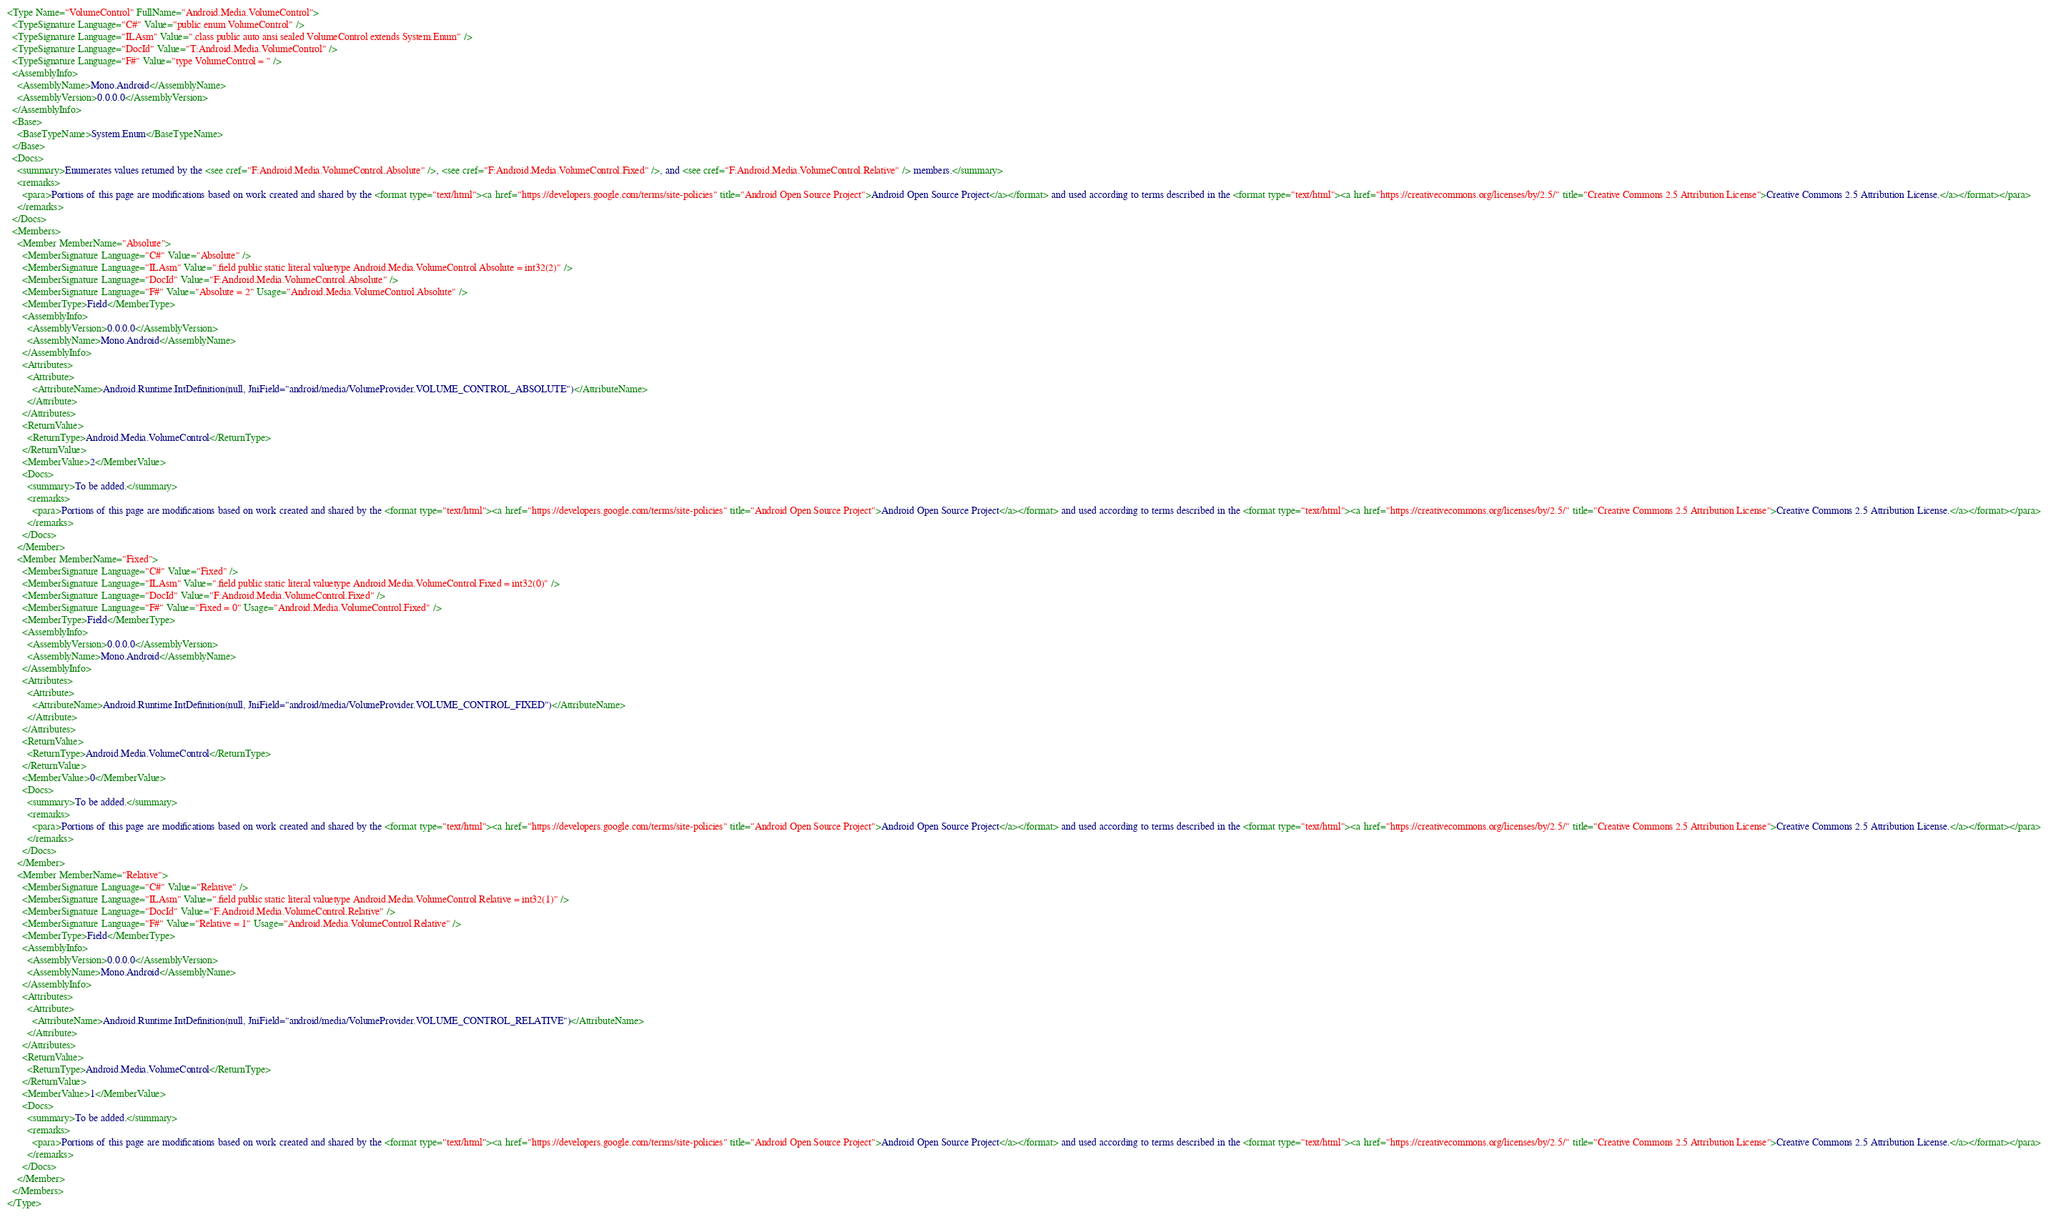Convert code to text. <code><loc_0><loc_0><loc_500><loc_500><_XML_><Type Name="VolumeControl" FullName="Android.Media.VolumeControl">
  <TypeSignature Language="C#" Value="public enum VolumeControl" />
  <TypeSignature Language="ILAsm" Value=".class public auto ansi sealed VolumeControl extends System.Enum" />
  <TypeSignature Language="DocId" Value="T:Android.Media.VolumeControl" />
  <TypeSignature Language="F#" Value="type VolumeControl = " />
  <AssemblyInfo>
    <AssemblyName>Mono.Android</AssemblyName>
    <AssemblyVersion>0.0.0.0</AssemblyVersion>
  </AssemblyInfo>
  <Base>
    <BaseTypeName>System.Enum</BaseTypeName>
  </Base>
  <Docs>
    <summary>Enumerates values returned by the <see cref="F:Android.Media.VolumeControl.Absolute" />, <see cref="F:Android.Media.VolumeControl.Fixed" />, and <see cref="F:Android.Media.VolumeControl.Relative" /> members.</summary>
    <remarks>
      <para>Portions of this page are modifications based on work created and shared by the <format type="text/html"><a href="https://developers.google.com/terms/site-policies" title="Android Open Source Project">Android Open Source Project</a></format> and used according to terms described in the <format type="text/html"><a href="https://creativecommons.org/licenses/by/2.5/" title="Creative Commons 2.5 Attribution License">Creative Commons 2.5 Attribution License.</a></format></para>
    </remarks>
  </Docs>
  <Members>
    <Member MemberName="Absolute">
      <MemberSignature Language="C#" Value="Absolute" />
      <MemberSignature Language="ILAsm" Value=".field public static literal valuetype Android.Media.VolumeControl Absolute = int32(2)" />
      <MemberSignature Language="DocId" Value="F:Android.Media.VolumeControl.Absolute" />
      <MemberSignature Language="F#" Value="Absolute = 2" Usage="Android.Media.VolumeControl.Absolute" />
      <MemberType>Field</MemberType>
      <AssemblyInfo>
        <AssemblyVersion>0.0.0.0</AssemblyVersion>
        <AssemblyName>Mono.Android</AssemblyName>
      </AssemblyInfo>
      <Attributes>
        <Attribute>
          <AttributeName>Android.Runtime.IntDefinition(null, JniField="android/media/VolumeProvider.VOLUME_CONTROL_ABSOLUTE")</AttributeName>
        </Attribute>
      </Attributes>
      <ReturnValue>
        <ReturnType>Android.Media.VolumeControl</ReturnType>
      </ReturnValue>
      <MemberValue>2</MemberValue>
      <Docs>
        <summary>To be added.</summary>
        <remarks>
          <para>Portions of this page are modifications based on work created and shared by the <format type="text/html"><a href="https://developers.google.com/terms/site-policies" title="Android Open Source Project">Android Open Source Project</a></format> and used according to terms described in the <format type="text/html"><a href="https://creativecommons.org/licenses/by/2.5/" title="Creative Commons 2.5 Attribution License">Creative Commons 2.5 Attribution License.</a></format></para>
        </remarks>
      </Docs>
    </Member>
    <Member MemberName="Fixed">
      <MemberSignature Language="C#" Value="Fixed" />
      <MemberSignature Language="ILAsm" Value=".field public static literal valuetype Android.Media.VolumeControl Fixed = int32(0)" />
      <MemberSignature Language="DocId" Value="F:Android.Media.VolumeControl.Fixed" />
      <MemberSignature Language="F#" Value="Fixed = 0" Usage="Android.Media.VolumeControl.Fixed" />
      <MemberType>Field</MemberType>
      <AssemblyInfo>
        <AssemblyVersion>0.0.0.0</AssemblyVersion>
        <AssemblyName>Mono.Android</AssemblyName>
      </AssemblyInfo>
      <Attributes>
        <Attribute>
          <AttributeName>Android.Runtime.IntDefinition(null, JniField="android/media/VolumeProvider.VOLUME_CONTROL_FIXED")</AttributeName>
        </Attribute>
      </Attributes>
      <ReturnValue>
        <ReturnType>Android.Media.VolumeControl</ReturnType>
      </ReturnValue>
      <MemberValue>0</MemberValue>
      <Docs>
        <summary>To be added.</summary>
        <remarks>
          <para>Portions of this page are modifications based on work created and shared by the <format type="text/html"><a href="https://developers.google.com/terms/site-policies" title="Android Open Source Project">Android Open Source Project</a></format> and used according to terms described in the <format type="text/html"><a href="https://creativecommons.org/licenses/by/2.5/" title="Creative Commons 2.5 Attribution License">Creative Commons 2.5 Attribution License.</a></format></para>
        </remarks>
      </Docs>
    </Member>
    <Member MemberName="Relative">
      <MemberSignature Language="C#" Value="Relative" />
      <MemberSignature Language="ILAsm" Value=".field public static literal valuetype Android.Media.VolumeControl Relative = int32(1)" />
      <MemberSignature Language="DocId" Value="F:Android.Media.VolumeControl.Relative" />
      <MemberSignature Language="F#" Value="Relative = 1" Usage="Android.Media.VolumeControl.Relative" />
      <MemberType>Field</MemberType>
      <AssemblyInfo>
        <AssemblyVersion>0.0.0.0</AssemblyVersion>
        <AssemblyName>Mono.Android</AssemblyName>
      </AssemblyInfo>
      <Attributes>
        <Attribute>
          <AttributeName>Android.Runtime.IntDefinition(null, JniField="android/media/VolumeProvider.VOLUME_CONTROL_RELATIVE")</AttributeName>
        </Attribute>
      </Attributes>
      <ReturnValue>
        <ReturnType>Android.Media.VolumeControl</ReturnType>
      </ReturnValue>
      <MemberValue>1</MemberValue>
      <Docs>
        <summary>To be added.</summary>
        <remarks>
          <para>Portions of this page are modifications based on work created and shared by the <format type="text/html"><a href="https://developers.google.com/terms/site-policies" title="Android Open Source Project">Android Open Source Project</a></format> and used according to terms described in the <format type="text/html"><a href="https://creativecommons.org/licenses/by/2.5/" title="Creative Commons 2.5 Attribution License">Creative Commons 2.5 Attribution License.</a></format></para>
        </remarks>
      </Docs>
    </Member>
  </Members>
</Type>
</code> 